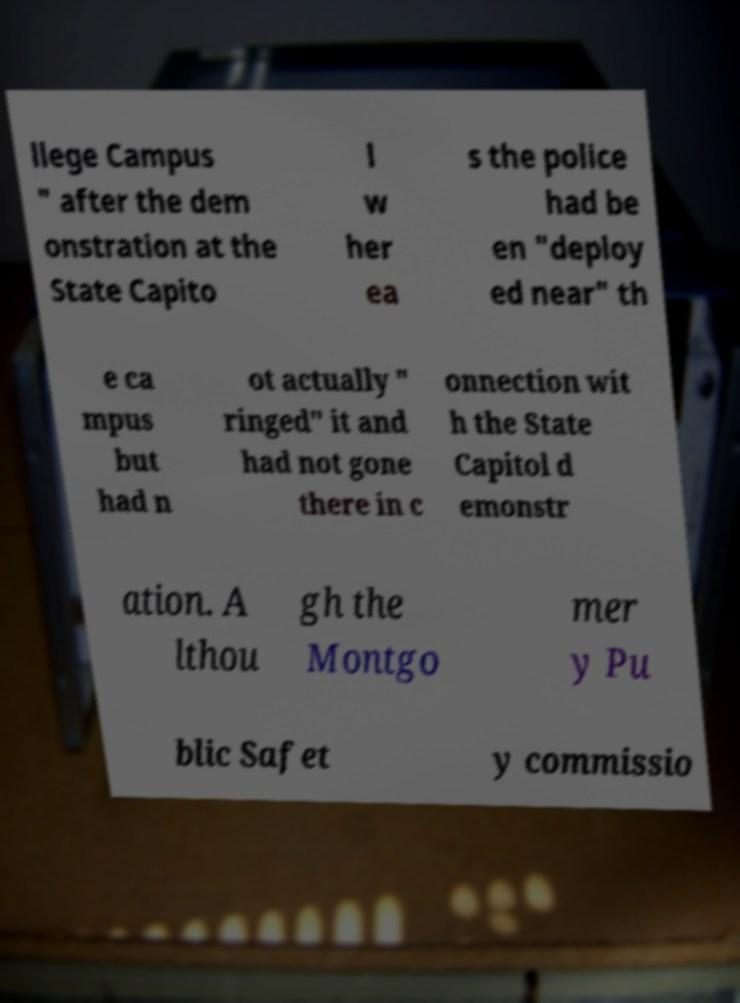Can you read and provide the text displayed in the image?This photo seems to have some interesting text. Can you extract and type it out for me? llege Campus " after the dem onstration at the State Capito l w her ea s the police had be en "deploy ed near" th e ca mpus but had n ot actually " ringed" it and had not gone there in c onnection wit h the State Capitol d emonstr ation. A lthou gh the Montgo mer y Pu blic Safet y commissio 